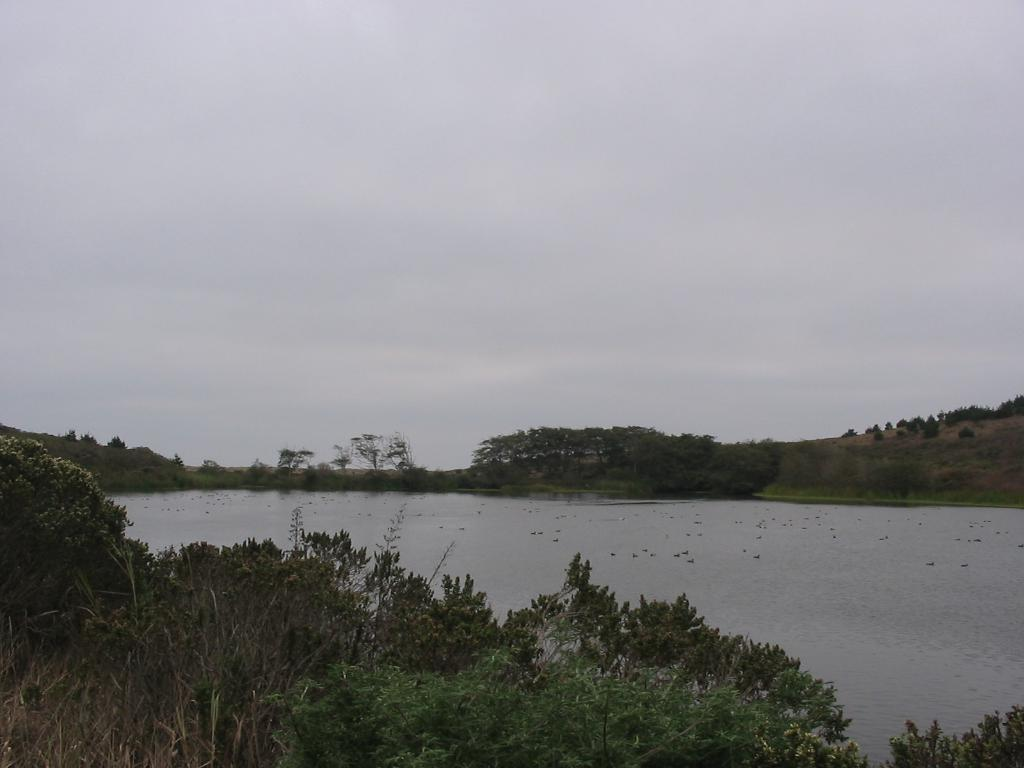What is the primary element visible in the image? There is water in the image. What other natural elements can be seen in the image? There are plants and trees in the image. What is visible at the top of the image? The sky is visible at the top of the image. What verse is being recited by the plants in the image? There are no verses or any form of communication being depicted by the plants in the image. 